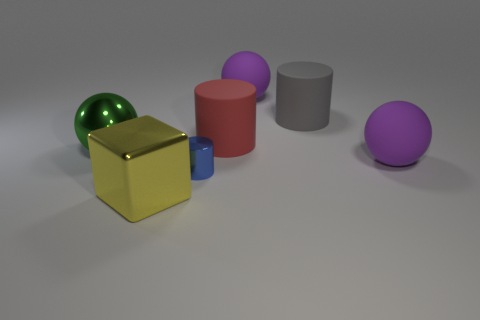Add 1 tiny brown spheres. How many objects exist? 8 Subtract all balls. How many objects are left? 4 Add 6 tiny objects. How many tiny objects exist? 7 Subtract 0 cyan balls. How many objects are left? 7 Subtract all big red matte things. Subtract all large cubes. How many objects are left? 5 Add 2 gray matte cylinders. How many gray matte cylinders are left? 3 